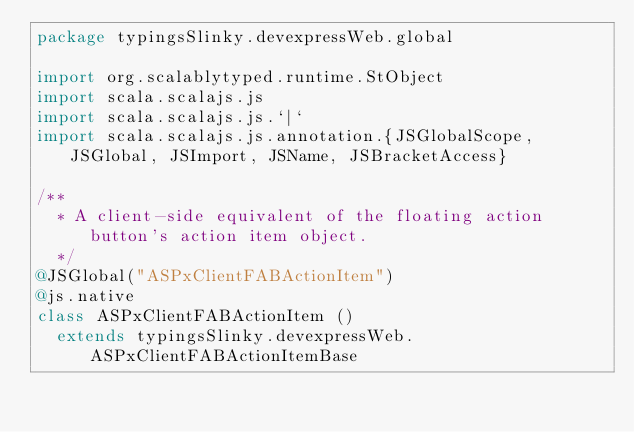Convert code to text. <code><loc_0><loc_0><loc_500><loc_500><_Scala_>package typingsSlinky.devexpressWeb.global

import org.scalablytyped.runtime.StObject
import scala.scalajs.js
import scala.scalajs.js.`|`
import scala.scalajs.js.annotation.{JSGlobalScope, JSGlobal, JSImport, JSName, JSBracketAccess}

/**
  * A client-side equivalent of the floating action button's action item object.
  */
@JSGlobal("ASPxClientFABActionItem")
@js.native
class ASPxClientFABActionItem ()
  extends typingsSlinky.devexpressWeb.ASPxClientFABActionItemBase
</code> 